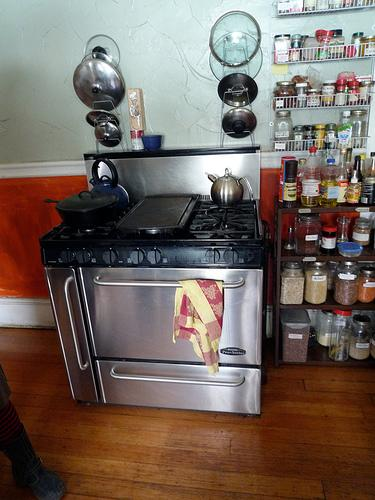What is next to the oven?

Choices:
A) spices
B) refrigerator
C) dishwasher
D) sink spices 